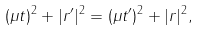Convert formula to latex. <formula><loc_0><loc_0><loc_500><loc_500>( \mu t ) ^ { 2 } + | r ^ { \prime } | ^ { 2 } = ( \mu t ^ { \prime } ) ^ { 2 } + | r | ^ { 2 } ,</formula> 